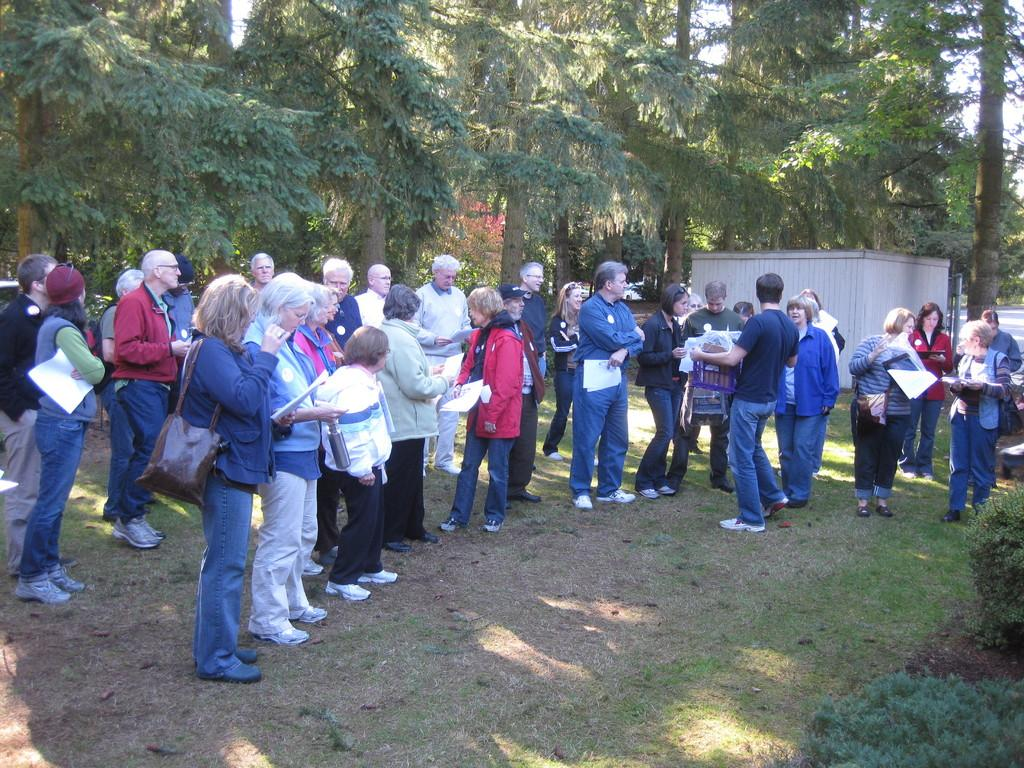What can be seen on the ground in the image? There are persons visible on the ground. What type of vegetation is present at the top of the image? There are trees at the top of the image. What type of structure is visible in front of the trees on the right side? There is a small tent house visible in front of the trees on the right side. What type of fact can be seen flying in the image? There is no fact visible in the image, and facts cannot fly. What type of metal is present in the image? There is no mention of any metal, such as zinc, in the image. 